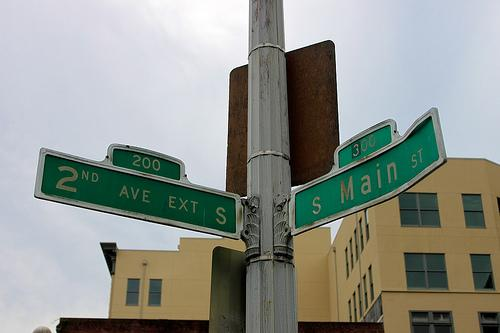Describe the image using simple words and compelling details. Two green signs say 2nd Ave and S Main St on a gray pole with tiny 200 and 300 blocks signs, a lovely blue sky above, and a big comfy tan-yellow building nearby. Mention the main objects and their colors in the image. Green street signs (2nd Ave and S Main St), gray pole, blue sky, tan-yellow building, small signs (200th and 300th blocks). Share what first grabs your attention in this image and any other significant features. My eyes are drawn to the green signs for 2nd Ave and S Main St, followed by the gray pole, smaller signs, the blue sky, and the tan-yellow building. Describe the setting of the image in a concise manner. A street corner with green signs on a gray pole, indicating 2nd Ave and S Main St, with a clear blue sky overhead and a tan-yellow building in the background. What are the five major components you can see in this image? Green street signs, gray pole, smaller block signs, clear blue sky, and a tan-yellow building. Provide a short and general overview of what can be seen in this image. The image features green street signs on a gray pole, a blue sky backdrop, and a large tan-yellow building in the distance. Can you provide a brief description of the main focus and any notable details in the image? There are two green street signs on a gray pole indicating 2nd Ave and S Main St, with smaller signs for 200th and 300th block, all against a clear blue sky and a tan-yellow building. What's the key point of interest in the picture, and what are the other noticeable elements? The green signs for 2nd Ave and S Main St stand out, along with a gray pole, smaller block signs, a blue sky, and a tan-yellow building. Tell me briefly about the main contents of the image, including the setting and any key objects or features. A street corner displays green signs for 2nd Ave and S Main St on a gray pole, with the backdrop of a clear blue sky and a large tan-yellow building. Describe the scene from the perspective of someone passing by. Walking by, I see the green signs for 2nd Ave and S Main St, the gray pole, small block signs, the clear blue sky, and a big tan-yellow building. 